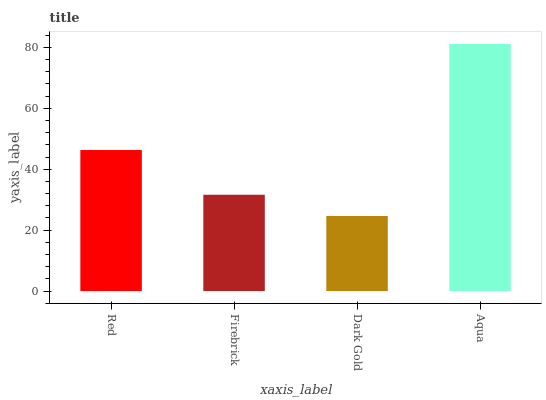Is Dark Gold the minimum?
Answer yes or no. Yes. Is Aqua the maximum?
Answer yes or no. Yes. Is Firebrick the minimum?
Answer yes or no. No. Is Firebrick the maximum?
Answer yes or no. No. Is Red greater than Firebrick?
Answer yes or no. Yes. Is Firebrick less than Red?
Answer yes or no. Yes. Is Firebrick greater than Red?
Answer yes or no. No. Is Red less than Firebrick?
Answer yes or no. No. Is Red the high median?
Answer yes or no. Yes. Is Firebrick the low median?
Answer yes or no. Yes. Is Firebrick the high median?
Answer yes or no. No. Is Aqua the low median?
Answer yes or no. No. 